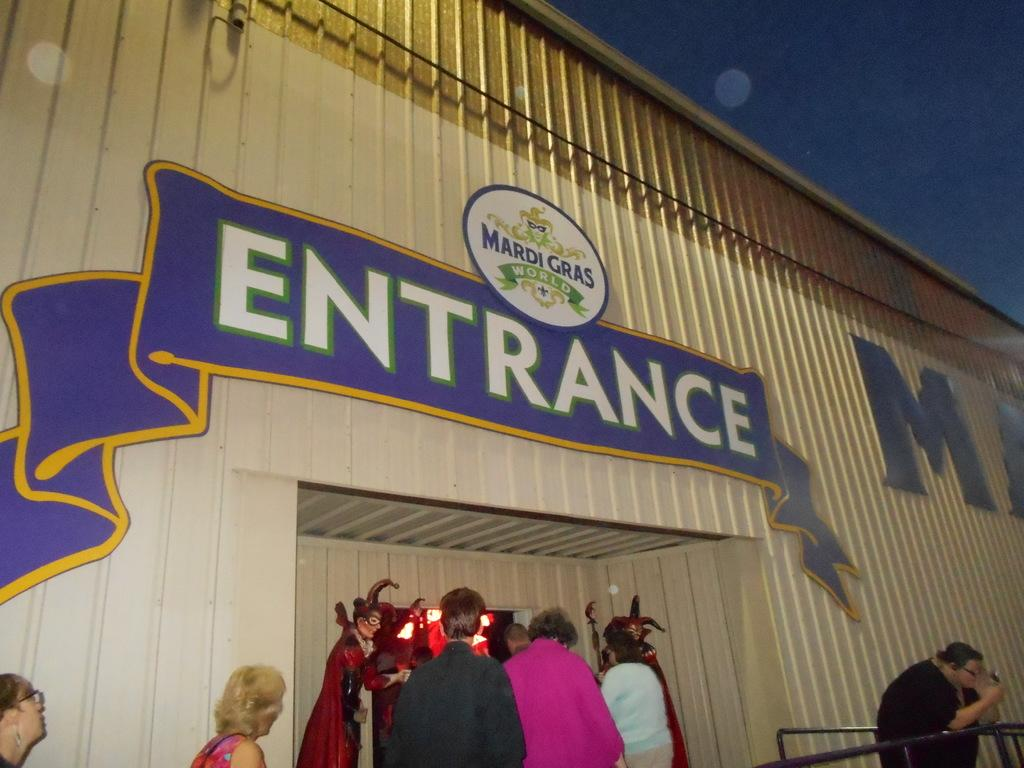How many people are visible in the image? There are many people standing in the image. What are some people wearing in the image? Some people are wearing red costumes. Where are the people standing in relation to the shop? The people are standing in front of an entrance to a shop. What can be seen on the entrance to the shop? There is text written on the entrance to the shop. What type of yarn is being used by the servant in the image? There is no servant or yarn present in the image. What hour of the day is depicted in the image? The image does not provide information about the time of day. 